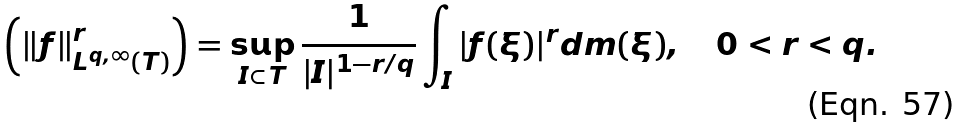Convert formula to latex. <formula><loc_0><loc_0><loc_500><loc_500>\left ( \| f \| ^ { r } _ { L ^ { q , \infty } ( T ) } \right ) = \sup _ { I \subset T } \frac { 1 } { | I | ^ { 1 - r / q } } \int _ { I } | f ( \xi ) | ^ { r } d m ( \xi ) , \quad 0 < r < q .</formula> 